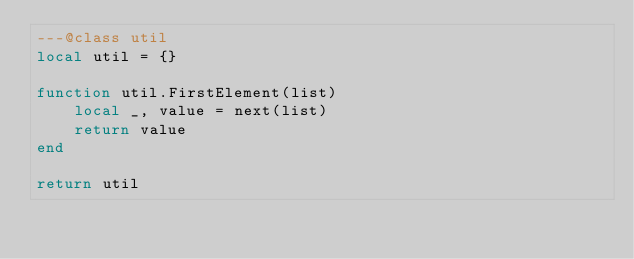Convert code to text. <code><loc_0><loc_0><loc_500><loc_500><_Lua_>---@class util
local util = {}

function util.FirstElement(list)
    local _, value = next(list)
    return value
end

return util
</code> 